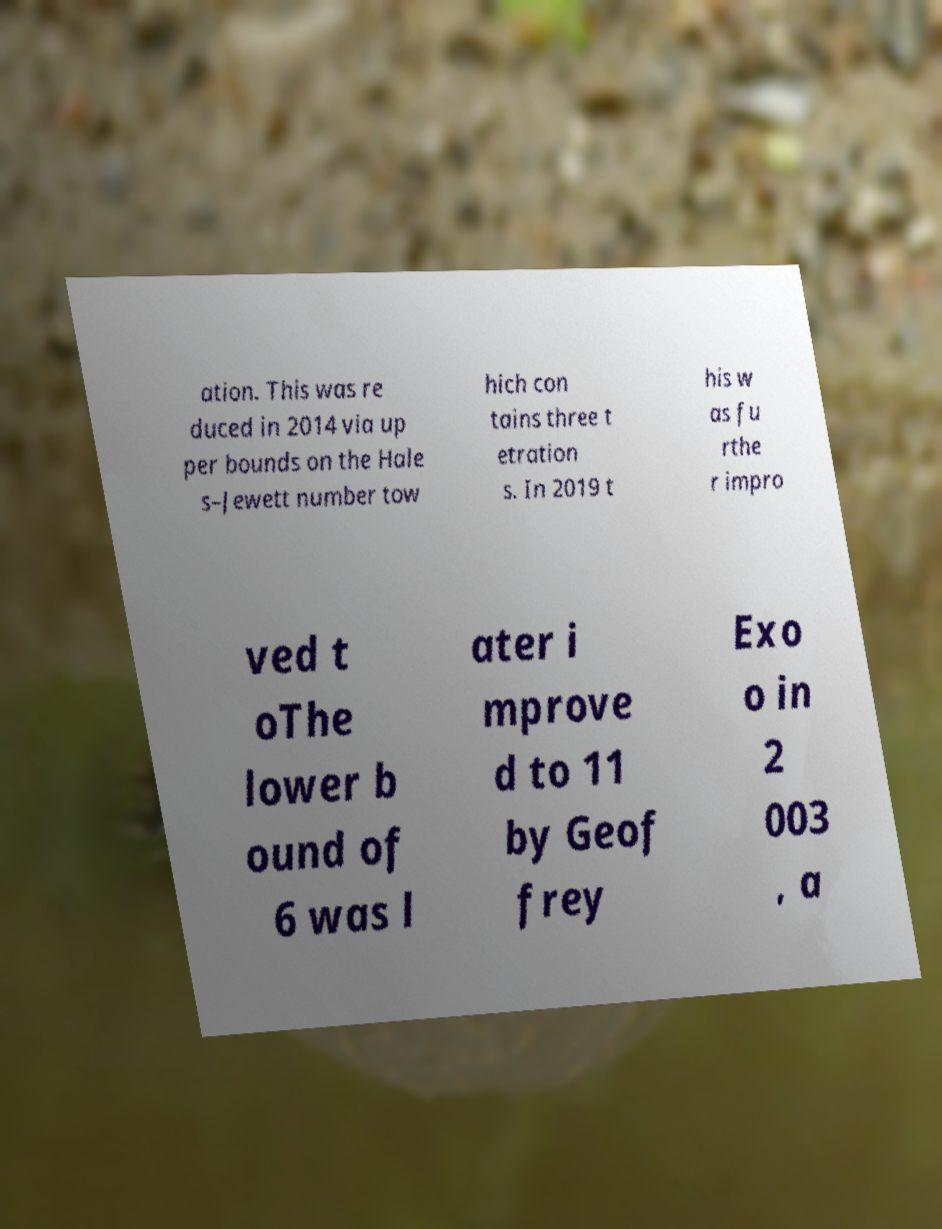Please read and relay the text visible in this image. What does it say? ation. This was re duced in 2014 via up per bounds on the Hale s–Jewett number tow hich con tains three t etration s. In 2019 t his w as fu rthe r impro ved t oThe lower b ound of 6 was l ater i mprove d to 11 by Geof frey Exo o in 2 003 , a 